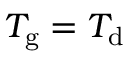Convert formula to latex. <formula><loc_0><loc_0><loc_500><loc_500>T _ { g } = T _ { d }</formula> 